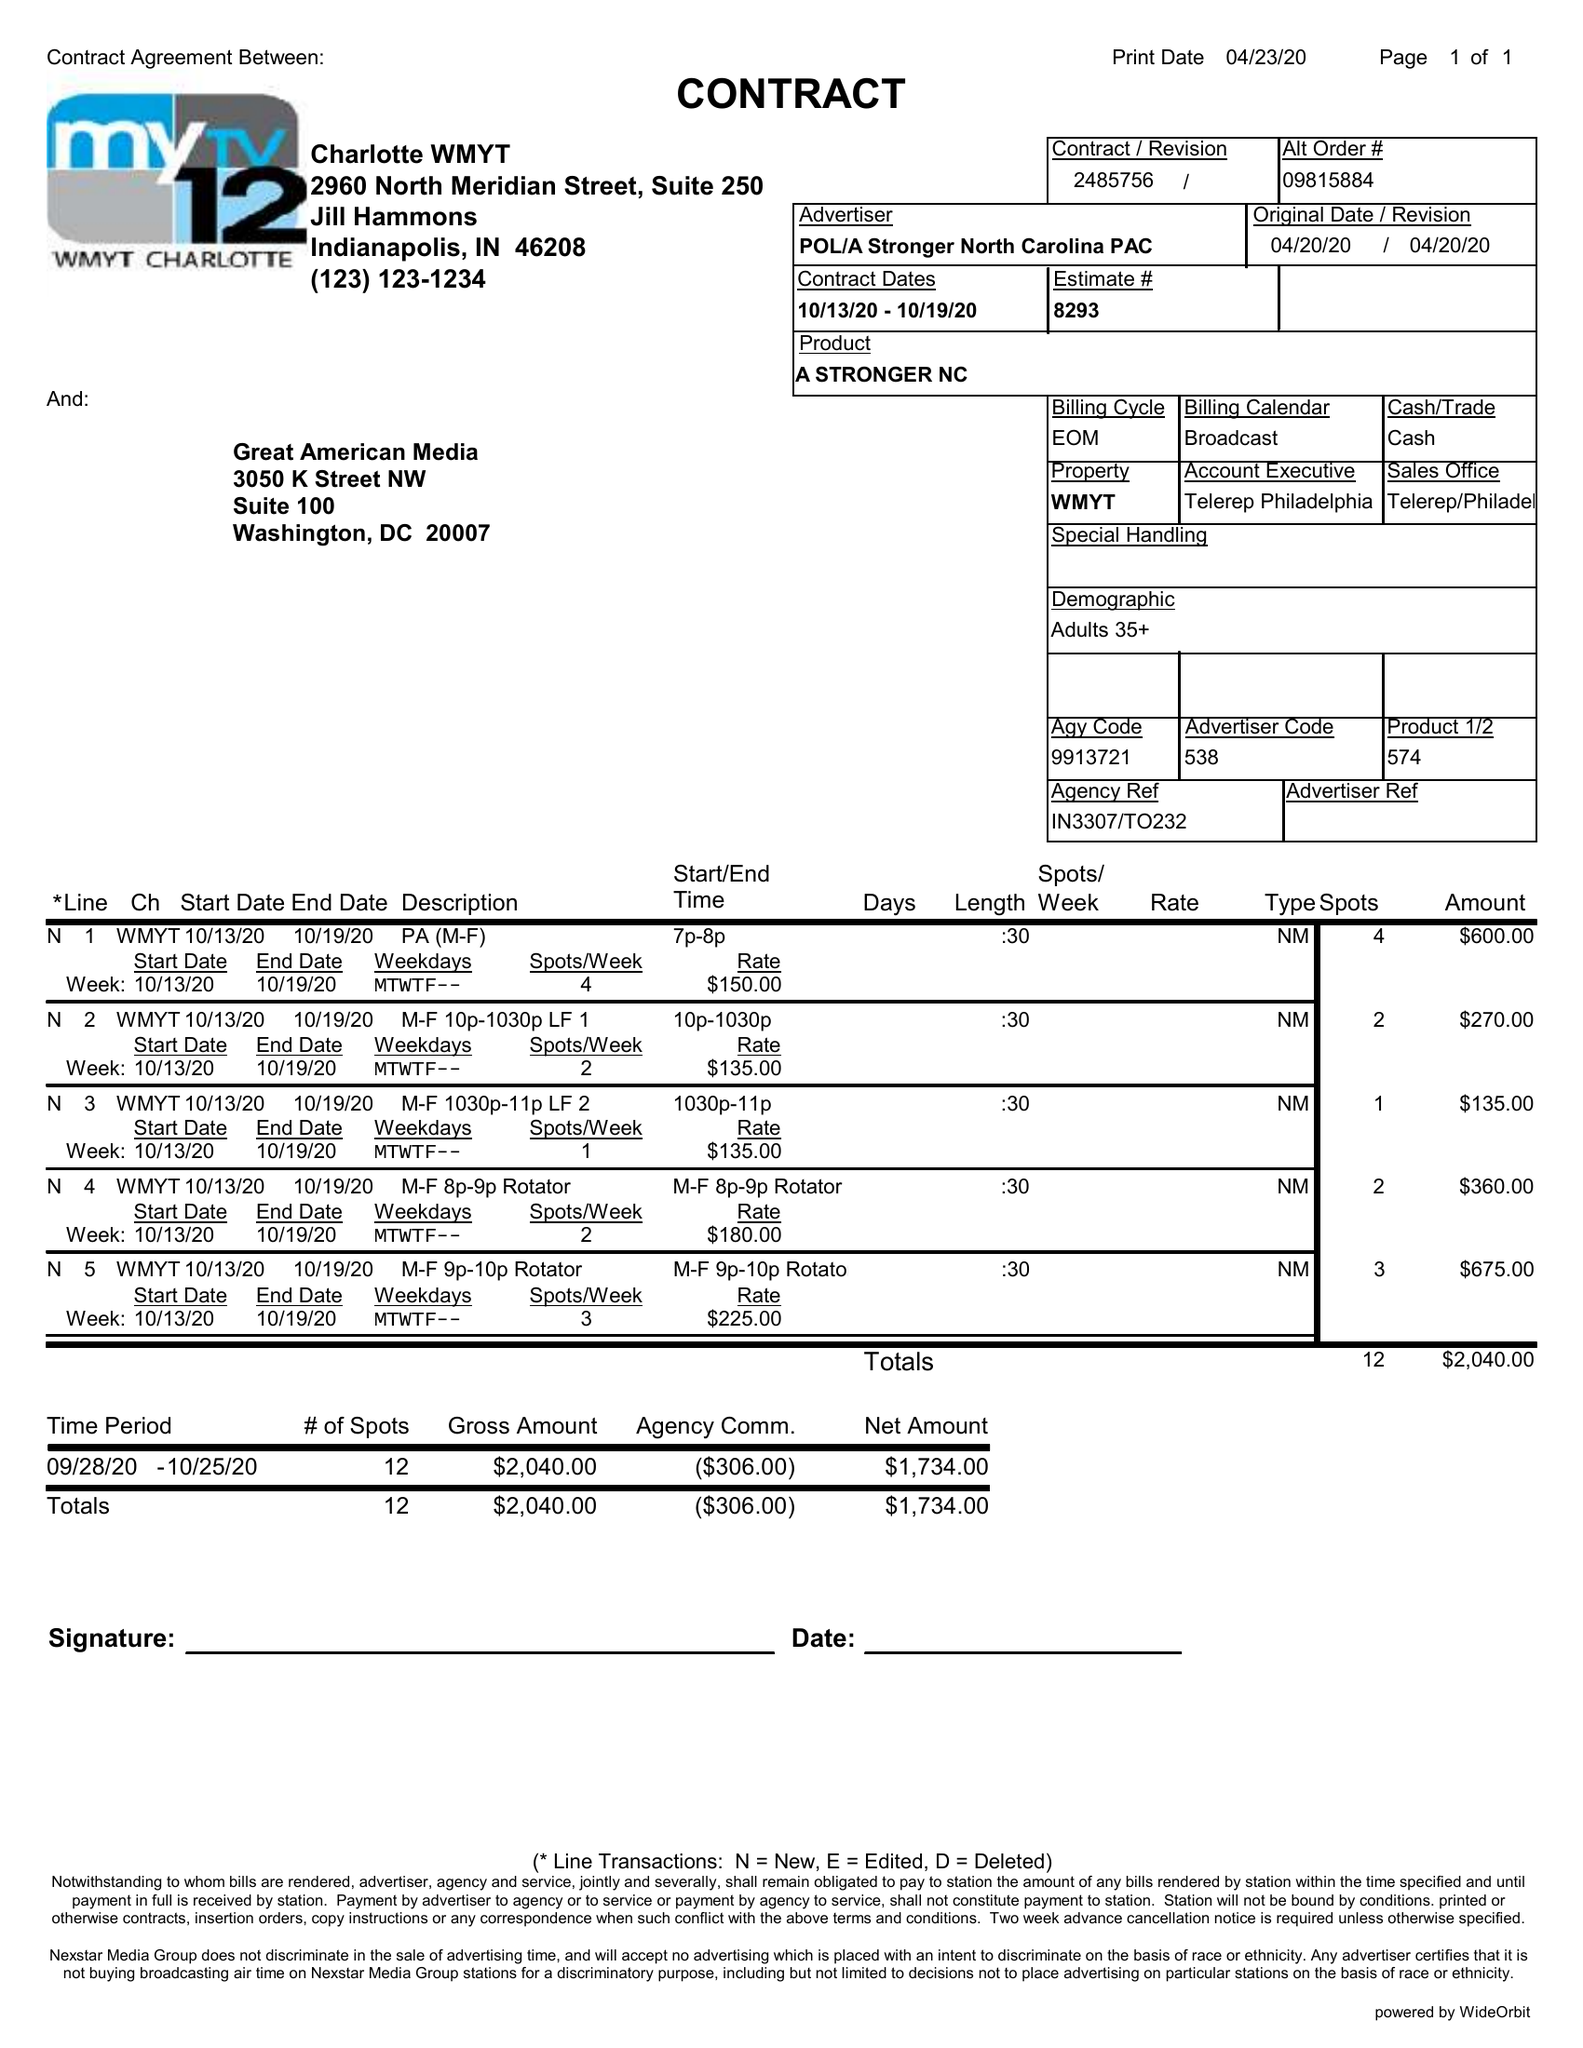What is the value for the flight_to?
Answer the question using a single word or phrase. 10/19/20 